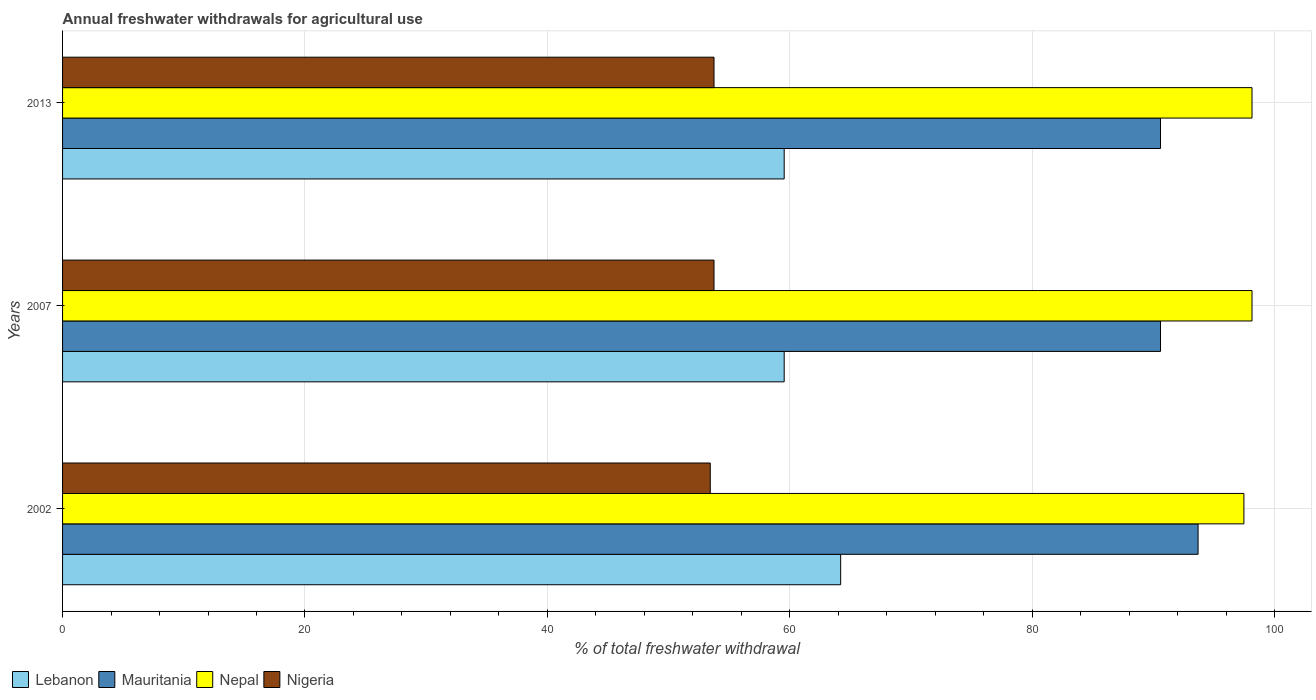How many different coloured bars are there?
Provide a short and direct response. 4. How many groups of bars are there?
Offer a very short reply. 3. Are the number of bars per tick equal to the number of legend labels?
Your answer should be compact. Yes. What is the label of the 3rd group of bars from the top?
Ensure brevity in your answer.  2002. What is the total annual withdrawals from freshwater in Lebanon in 2002?
Provide a succinct answer. 64.2. Across all years, what is the maximum total annual withdrawals from freshwater in Nigeria?
Offer a very short reply. 53.75. Across all years, what is the minimum total annual withdrawals from freshwater in Nepal?
Your response must be concise. 97.47. In which year was the total annual withdrawals from freshwater in Mauritania maximum?
Offer a very short reply. 2002. In which year was the total annual withdrawals from freshwater in Nepal minimum?
Ensure brevity in your answer.  2002. What is the total total annual withdrawals from freshwater in Mauritania in the graph?
Keep it short and to the point. 274.87. What is the difference between the total annual withdrawals from freshwater in Mauritania in 2002 and that in 2007?
Your response must be concise. 3.1. What is the difference between the total annual withdrawals from freshwater in Nepal in 2013 and the total annual withdrawals from freshwater in Lebanon in 2007?
Offer a very short reply. 38.6. What is the average total annual withdrawals from freshwater in Mauritania per year?
Provide a short and direct response. 91.62. In the year 2002, what is the difference between the total annual withdrawals from freshwater in Nigeria and total annual withdrawals from freshwater in Lebanon?
Your response must be concise. -10.76. What is the ratio of the total annual withdrawals from freshwater in Nigeria in 2002 to that in 2013?
Your answer should be very brief. 0.99. Is the total annual withdrawals from freshwater in Nepal in 2002 less than that in 2007?
Give a very brief answer. Yes. Is the difference between the total annual withdrawals from freshwater in Nigeria in 2007 and 2013 greater than the difference between the total annual withdrawals from freshwater in Lebanon in 2007 and 2013?
Ensure brevity in your answer.  No. What is the difference between the highest and the second highest total annual withdrawals from freshwater in Mauritania?
Make the answer very short. 3.1. What is the difference between the highest and the lowest total annual withdrawals from freshwater in Nigeria?
Provide a short and direct response. 0.31. In how many years, is the total annual withdrawals from freshwater in Lebanon greater than the average total annual withdrawals from freshwater in Lebanon taken over all years?
Make the answer very short. 1. What does the 4th bar from the top in 2007 represents?
Keep it short and to the point. Lebanon. What does the 1st bar from the bottom in 2002 represents?
Offer a very short reply. Lebanon. Is it the case that in every year, the sum of the total annual withdrawals from freshwater in Mauritania and total annual withdrawals from freshwater in Lebanon is greater than the total annual withdrawals from freshwater in Nepal?
Provide a short and direct response. Yes. How many bars are there?
Your response must be concise. 12. Are all the bars in the graph horizontal?
Your response must be concise. Yes. How many years are there in the graph?
Your answer should be very brief. 3. Are the values on the major ticks of X-axis written in scientific E-notation?
Give a very brief answer. No. Does the graph contain any zero values?
Keep it short and to the point. No. Does the graph contain grids?
Offer a terse response. Yes. What is the title of the graph?
Keep it short and to the point. Annual freshwater withdrawals for agricultural use. Does "Belize" appear as one of the legend labels in the graph?
Your answer should be compact. No. What is the label or title of the X-axis?
Offer a very short reply. % of total freshwater withdrawal. What is the % of total freshwater withdrawal in Lebanon in 2002?
Make the answer very short. 64.2. What is the % of total freshwater withdrawal of Mauritania in 2002?
Provide a succinct answer. 93.69. What is the % of total freshwater withdrawal of Nepal in 2002?
Provide a short and direct response. 97.47. What is the % of total freshwater withdrawal of Nigeria in 2002?
Keep it short and to the point. 53.44. What is the % of total freshwater withdrawal in Lebanon in 2007?
Provide a short and direct response. 59.54. What is the % of total freshwater withdrawal in Mauritania in 2007?
Offer a very short reply. 90.59. What is the % of total freshwater withdrawal in Nepal in 2007?
Ensure brevity in your answer.  98.14. What is the % of total freshwater withdrawal of Nigeria in 2007?
Offer a terse response. 53.75. What is the % of total freshwater withdrawal of Lebanon in 2013?
Provide a succinct answer. 59.54. What is the % of total freshwater withdrawal of Mauritania in 2013?
Your response must be concise. 90.59. What is the % of total freshwater withdrawal of Nepal in 2013?
Your answer should be compact. 98.14. What is the % of total freshwater withdrawal of Nigeria in 2013?
Your response must be concise. 53.75. Across all years, what is the maximum % of total freshwater withdrawal in Lebanon?
Provide a succinct answer. 64.2. Across all years, what is the maximum % of total freshwater withdrawal of Mauritania?
Your answer should be very brief. 93.69. Across all years, what is the maximum % of total freshwater withdrawal in Nepal?
Provide a short and direct response. 98.14. Across all years, what is the maximum % of total freshwater withdrawal in Nigeria?
Keep it short and to the point. 53.75. Across all years, what is the minimum % of total freshwater withdrawal in Lebanon?
Your answer should be compact. 59.54. Across all years, what is the minimum % of total freshwater withdrawal of Mauritania?
Make the answer very short. 90.59. Across all years, what is the minimum % of total freshwater withdrawal of Nepal?
Provide a short and direct response. 97.47. Across all years, what is the minimum % of total freshwater withdrawal of Nigeria?
Offer a terse response. 53.44. What is the total % of total freshwater withdrawal of Lebanon in the graph?
Offer a terse response. 183.28. What is the total % of total freshwater withdrawal in Mauritania in the graph?
Give a very brief answer. 274.87. What is the total % of total freshwater withdrawal of Nepal in the graph?
Give a very brief answer. 293.75. What is the total % of total freshwater withdrawal of Nigeria in the graph?
Your answer should be very brief. 160.94. What is the difference between the % of total freshwater withdrawal in Lebanon in 2002 and that in 2007?
Your answer should be compact. 4.66. What is the difference between the % of total freshwater withdrawal in Mauritania in 2002 and that in 2007?
Give a very brief answer. 3.1. What is the difference between the % of total freshwater withdrawal of Nepal in 2002 and that in 2007?
Give a very brief answer. -0.67. What is the difference between the % of total freshwater withdrawal in Nigeria in 2002 and that in 2007?
Your answer should be very brief. -0.31. What is the difference between the % of total freshwater withdrawal in Lebanon in 2002 and that in 2013?
Give a very brief answer. 4.66. What is the difference between the % of total freshwater withdrawal of Mauritania in 2002 and that in 2013?
Your response must be concise. 3.1. What is the difference between the % of total freshwater withdrawal of Nepal in 2002 and that in 2013?
Ensure brevity in your answer.  -0.67. What is the difference between the % of total freshwater withdrawal of Nigeria in 2002 and that in 2013?
Provide a short and direct response. -0.31. What is the difference between the % of total freshwater withdrawal of Lebanon in 2007 and that in 2013?
Provide a short and direct response. 0. What is the difference between the % of total freshwater withdrawal in Mauritania in 2007 and that in 2013?
Provide a succinct answer. 0. What is the difference between the % of total freshwater withdrawal of Nigeria in 2007 and that in 2013?
Ensure brevity in your answer.  0. What is the difference between the % of total freshwater withdrawal of Lebanon in 2002 and the % of total freshwater withdrawal of Mauritania in 2007?
Provide a short and direct response. -26.39. What is the difference between the % of total freshwater withdrawal in Lebanon in 2002 and the % of total freshwater withdrawal in Nepal in 2007?
Your response must be concise. -33.94. What is the difference between the % of total freshwater withdrawal in Lebanon in 2002 and the % of total freshwater withdrawal in Nigeria in 2007?
Ensure brevity in your answer.  10.45. What is the difference between the % of total freshwater withdrawal of Mauritania in 2002 and the % of total freshwater withdrawal of Nepal in 2007?
Make the answer very short. -4.45. What is the difference between the % of total freshwater withdrawal in Mauritania in 2002 and the % of total freshwater withdrawal in Nigeria in 2007?
Provide a succinct answer. 39.94. What is the difference between the % of total freshwater withdrawal of Nepal in 2002 and the % of total freshwater withdrawal of Nigeria in 2007?
Keep it short and to the point. 43.72. What is the difference between the % of total freshwater withdrawal in Lebanon in 2002 and the % of total freshwater withdrawal in Mauritania in 2013?
Provide a succinct answer. -26.39. What is the difference between the % of total freshwater withdrawal of Lebanon in 2002 and the % of total freshwater withdrawal of Nepal in 2013?
Your answer should be very brief. -33.94. What is the difference between the % of total freshwater withdrawal of Lebanon in 2002 and the % of total freshwater withdrawal of Nigeria in 2013?
Offer a terse response. 10.45. What is the difference between the % of total freshwater withdrawal of Mauritania in 2002 and the % of total freshwater withdrawal of Nepal in 2013?
Offer a terse response. -4.45. What is the difference between the % of total freshwater withdrawal of Mauritania in 2002 and the % of total freshwater withdrawal of Nigeria in 2013?
Offer a terse response. 39.94. What is the difference between the % of total freshwater withdrawal of Nepal in 2002 and the % of total freshwater withdrawal of Nigeria in 2013?
Make the answer very short. 43.72. What is the difference between the % of total freshwater withdrawal of Lebanon in 2007 and the % of total freshwater withdrawal of Mauritania in 2013?
Make the answer very short. -31.05. What is the difference between the % of total freshwater withdrawal of Lebanon in 2007 and the % of total freshwater withdrawal of Nepal in 2013?
Provide a short and direct response. -38.6. What is the difference between the % of total freshwater withdrawal of Lebanon in 2007 and the % of total freshwater withdrawal of Nigeria in 2013?
Your answer should be compact. 5.79. What is the difference between the % of total freshwater withdrawal in Mauritania in 2007 and the % of total freshwater withdrawal in Nepal in 2013?
Provide a succinct answer. -7.55. What is the difference between the % of total freshwater withdrawal of Mauritania in 2007 and the % of total freshwater withdrawal of Nigeria in 2013?
Offer a terse response. 36.84. What is the difference between the % of total freshwater withdrawal in Nepal in 2007 and the % of total freshwater withdrawal in Nigeria in 2013?
Make the answer very short. 44.39. What is the average % of total freshwater withdrawal of Lebanon per year?
Give a very brief answer. 61.09. What is the average % of total freshwater withdrawal of Mauritania per year?
Offer a terse response. 91.62. What is the average % of total freshwater withdrawal in Nepal per year?
Your answer should be compact. 97.92. What is the average % of total freshwater withdrawal in Nigeria per year?
Offer a very short reply. 53.65. In the year 2002, what is the difference between the % of total freshwater withdrawal in Lebanon and % of total freshwater withdrawal in Mauritania?
Give a very brief answer. -29.49. In the year 2002, what is the difference between the % of total freshwater withdrawal in Lebanon and % of total freshwater withdrawal in Nepal?
Your answer should be very brief. -33.27. In the year 2002, what is the difference between the % of total freshwater withdrawal in Lebanon and % of total freshwater withdrawal in Nigeria?
Offer a very short reply. 10.76. In the year 2002, what is the difference between the % of total freshwater withdrawal in Mauritania and % of total freshwater withdrawal in Nepal?
Ensure brevity in your answer.  -3.78. In the year 2002, what is the difference between the % of total freshwater withdrawal of Mauritania and % of total freshwater withdrawal of Nigeria?
Give a very brief answer. 40.25. In the year 2002, what is the difference between the % of total freshwater withdrawal in Nepal and % of total freshwater withdrawal in Nigeria?
Make the answer very short. 44.03. In the year 2007, what is the difference between the % of total freshwater withdrawal of Lebanon and % of total freshwater withdrawal of Mauritania?
Give a very brief answer. -31.05. In the year 2007, what is the difference between the % of total freshwater withdrawal of Lebanon and % of total freshwater withdrawal of Nepal?
Your response must be concise. -38.6. In the year 2007, what is the difference between the % of total freshwater withdrawal of Lebanon and % of total freshwater withdrawal of Nigeria?
Your answer should be compact. 5.79. In the year 2007, what is the difference between the % of total freshwater withdrawal in Mauritania and % of total freshwater withdrawal in Nepal?
Your answer should be compact. -7.55. In the year 2007, what is the difference between the % of total freshwater withdrawal in Mauritania and % of total freshwater withdrawal in Nigeria?
Make the answer very short. 36.84. In the year 2007, what is the difference between the % of total freshwater withdrawal in Nepal and % of total freshwater withdrawal in Nigeria?
Offer a terse response. 44.39. In the year 2013, what is the difference between the % of total freshwater withdrawal of Lebanon and % of total freshwater withdrawal of Mauritania?
Your answer should be compact. -31.05. In the year 2013, what is the difference between the % of total freshwater withdrawal in Lebanon and % of total freshwater withdrawal in Nepal?
Give a very brief answer. -38.6. In the year 2013, what is the difference between the % of total freshwater withdrawal in Lebanon and % of total freshwater withdrawal in Nigeria?
Provide a succinct answer. 5.79. In the year 2013, what is the difference between the % of total freshwater withdrawal of Mauritania and % of total freshwater withdrawal of Nepal?
Your response must be concise. -7.55. In the year 2013, what is the difference between the % of total freshwater withdrawal in Mauritania and % of total freshwater withdrawal in Nigeria?
Your response must be concise. 36.84. In the year 2013, what is the difference between the % of total freshwater withdrawal in Nepal and % of total freshwater withdrawal in Nigeria?
Your answer should be very brief. 44.39. What is the ratio of the % of total freshwater withdrawal in Lebanon in 2002 to that in 2007?
Ensure brevity in your answer.  1.08. What is the ratio of the % of total freshwater withdrawal of Mauritania in 2002 to that in 2007?
Offer a very short reply. 1.03. What is the ratio of the % of total freshwater withdrawal of Nepal in 2002 to that in 2007?
Your answer should be compact. 0.99. What is the ratio of the % of total freshwater withdrawal of Lebanon in 2002 to that in 2013?
Provide a short and direct response. 1.08. What is the ratio of the % of total freshwater withdrawal of Mauritania in 2002 to that in 2013?
Ensure brevity in your answer.  1.03. What is the ratio of the % of total freshwater withdrawal of Nepal in 2002 to that in 2013?
Give a very brief answer. 0.99. What is the ratio of the % of total freshwater withdrawal of Lebanon in 2007 to that in 2013?
Give a very brief answer. 1. What is the ratio of the % of total freshwater withdrawal of Nepal in 2007 to that in 2013?
Keep it short and to the point. 1. What is the difference between the highest and the second highest % of total freshwater withdrawal of Lebanon?
Keep it short and to the point. 4.66. What is the difference between the highest and the second highest % of total freshwater withdrawal in Nepal?
Your response must be concise. 0. What is the difference between the highest and the second highest % of total freshwater withdrawal in Nigeria?
Your answer should be very brief. 0. What is the difference between the highest and the lowest % of total freshwater withdrawal of Lebanon?
Keep it short and to the point. 4.66. What is the difference between the highest and the lowest % of total freshwater withdrawal of Mauritania?
Your answer should be compact. 3.1. What is the difference between the highest and the lowest % of total freshwater withdrawal in Nepal?
Make the answer very short. 0.67. What is the difference between the highest and the lowest % of total freshwater withdrawal of Nigeria?
Keep it short and to the point. 0.31. 